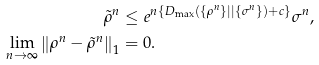Convert formula to latex. <formula><loc_0><loc_0><loc_500><loc_500>\tilde { \rho } ^ { n } & \leq e ^ { n \left \{ D _ { \max } \left ( \{ \rho ^ { n } \} | | \{ \sigma ^ { n } \} \right ) + c \right \} } \sigma ^ { n } , \, \\ \, \lim _ { n \rightarrow \infty } \left \| \rho ^ { n } - \tilde { \rho } ^ { n } \right \| _ { 1 } & = 0 .</formula> 